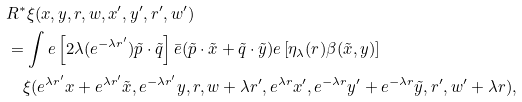<formula> <loc_0><loc_0><loc_500><loc_500>& R ^ { * } \xi ( x , y , r , w , x ^ { \prime } , y ^ { \prime } , r ^ { \prime } , w ^ { \prime } ) \\ & = \int e \left [ 2 \lambda ( e ^ { - \lambda r ^ { \prime } } ) \tilde { p } \cdot \tilde { q } \right ] \bar { e } ( \tilde { p } \cdot \tilde { x } + \tilde { q } \cdot \tilde { y } ) e \left [ \eta _ { \lambda } ( r ) \beta ( \tilde { x } , y ) \right ] \\ & \quad \xi ( e ^ { \lambda r ^ { \prime } } x + e ^ { \lambda r ^ { \prime } } \tilde { x } , e ^ { - \lambda r ^ { \prime } } y , r , w + \lambda r ^ { \prime } , e ^ { \lambda r } x ^ { \prime } , e ^ { - \lambda r } y ^ { \prime } + e ^ { - \lambda r } \tilde { y } , r ^ { \prime } , w ^ { \prime } + \lambda r ) ,</formula> 